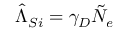<formula> <loc_0><loc_0><loc_500><loc_500>\hat { \Lambda } _ { S i } = \gamma _ { D } \tilde { N } _ { e }</formula> 